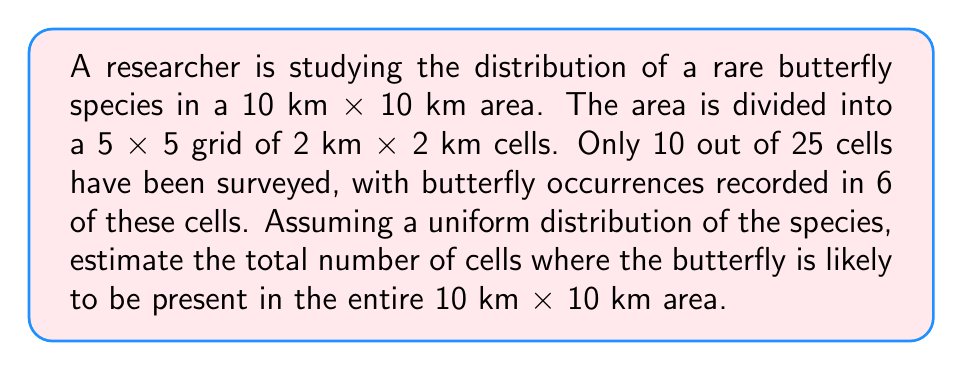What is the answer to this math problem? To solve this inverse problem and estimate the total number of cells with butterfly presence, we'll follow these steps:

1. Calculate the proportion of surveyed cells with butterfly presence:
   $$p = \frac{\text{Cells with butterfly presence}}{\text{Total surveyed cells}} = \frac{6}{10} = 0.6$$

2. Assume this proportion applies to the entire area (uniform distribution assumption).

3. Calculate the estimated number of cells with butterfly presence in the entire area:
   $$\text{Estimated cells} = p \times \text{Total cells in the area}$$
   $$\text{Estimated cells} = 0.6 \times 25 = 15$$

4. Since we're dealing with whole cells, round to the nearest integer:
   $$\text{Rounded estimate} = \text{round}(15) = 15$$

This method uses the principle of maximum likelihood estimation, where we assume the observed proportion in the sampled area represents the true proportion across the entire region.
Answer: 15 cells 